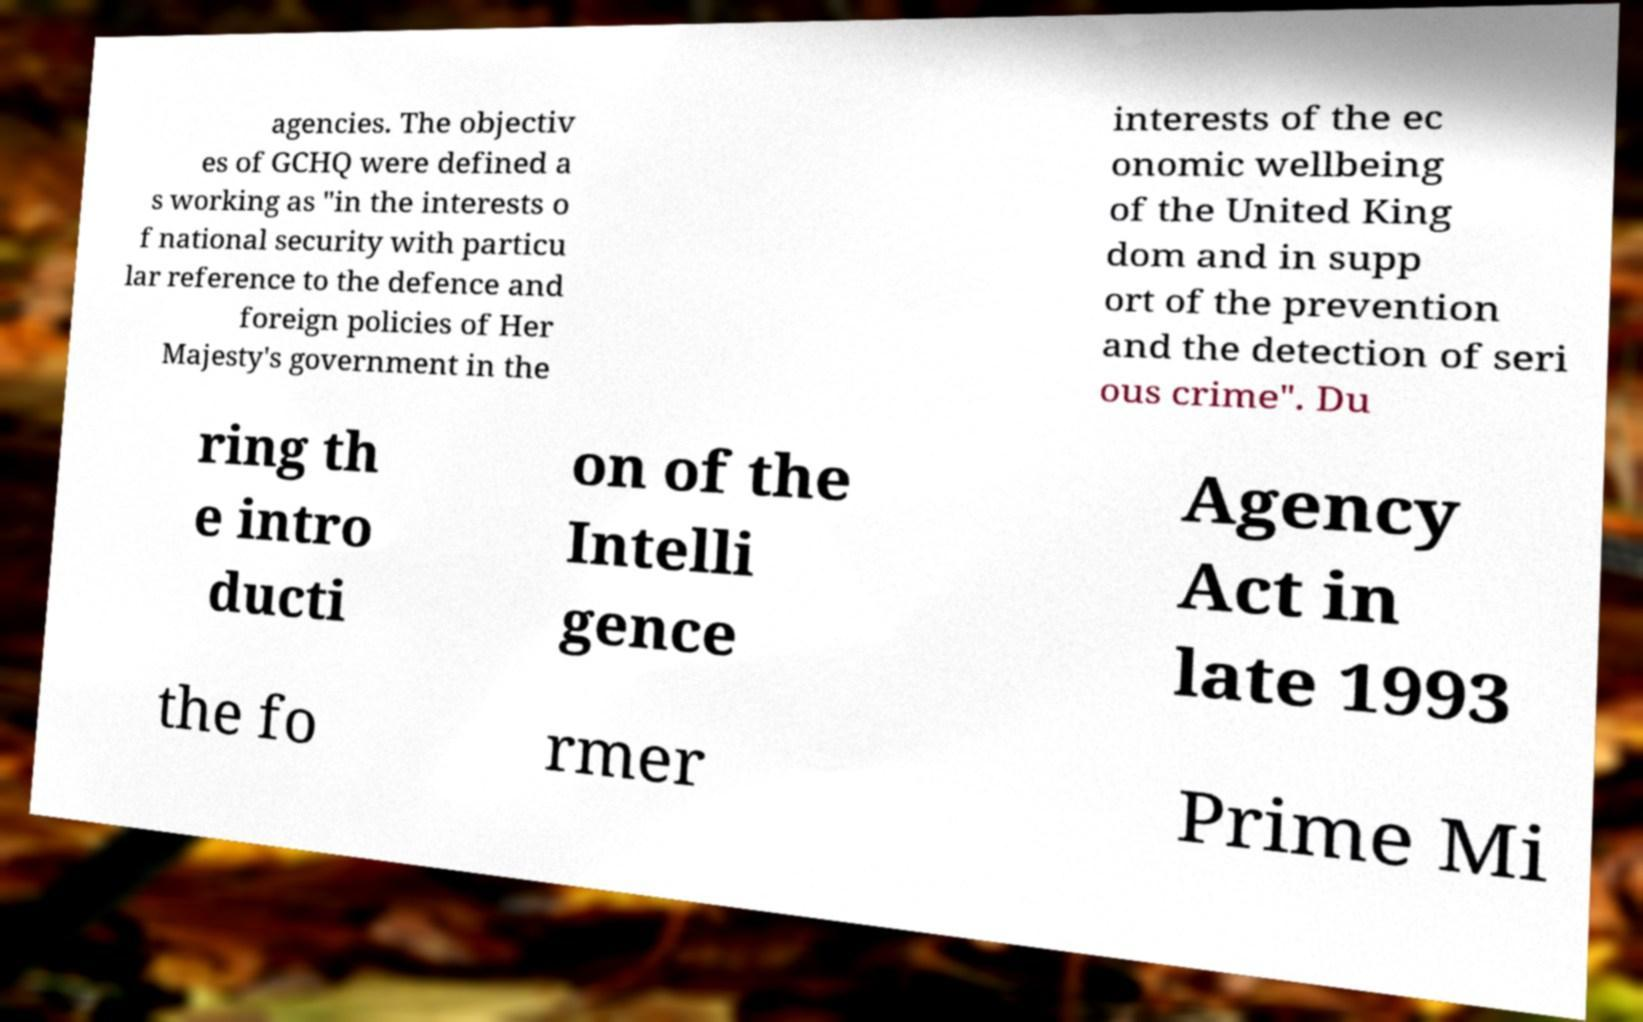Could you assist in decoding the text presented in this image and type it out clearly? agencies. The objectiv es of GCHQ were defined a s working as "in the interests o f national security with particu lar reference to the defence and foreign policies of Her Majesty's government in the interests of the ec onomic wellbeing of the United King dom and in supp ort of the prevention and the detection of seri ous crime". Du ring th e intro ducti on of the Intelli gence Agency Act in late 1993 the fo rmer Prime Mi 